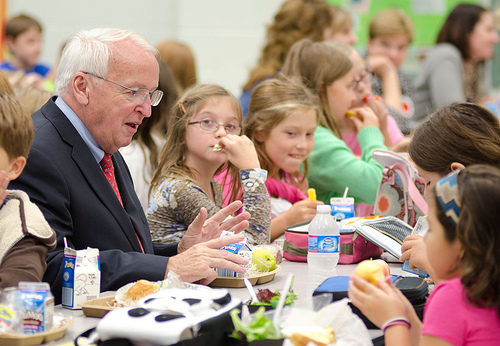<image>
Is the girl behind the man? Yes. From this viewpoint, the girl is positioned behind the man, with the man partially or fully occluding the girl. Where is the apple in relation to the girl? Is it in the girl? Yes. The apple is contained within or inside the girl, showing a containment relationship. 